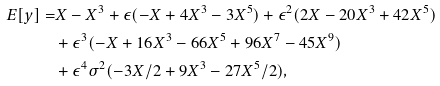<formula> <loc_0><loc_0><loc_500><loc_500>E [ y ] = & X - X ^ { 3 } + \epsilon ( - X + 4 X ^ { 3 } - 3 X ^ { 5 } ) + \epsilon ^ { 2 } ( 2 X - 2 0 X ^ { 3 } + 4 2 X ^ { 5 } ) \\ & + \epsilon ^ { 3 } ( - X + 1 6 X ^ { 3 } - 6 6 X ^ { 5 } + 9 6 X ^ { 7 } - 4 5 X ^ { 9 } ) \\ & + \epsilon ^ { 4 } \sigma ^ { 2 } ( - 3 X / 2 + 9 X ^ { 3 } - 2 7 X ^ { 5 } / 2 ) ,</formula> 